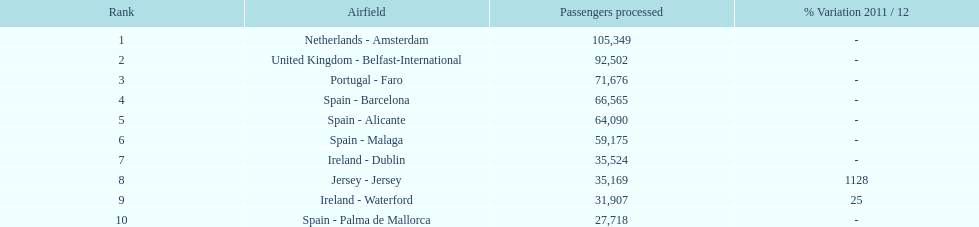What is the name of the only airport in portugal that is among the 10 busiest routes to and from london southend airport in 2012? Portugal - Faro. Give me the full table as a dictionary. {'header': ['Rank', 'Airfield', 'Passengers processed', '% Variation 2011 / 12'], 'rows': [['1', 'Netherlands - Amsterdam', '105,349', '-'], ['2', 'United Kingdom - Belfast-International', '92,502', '-'], ['3', 'Portugal - Faro', '71,676', '-'], ['4', 'Spain - Barcelona', '66,565', '-'], ['5', 'Spain - Alicante', '64,090', '-'], ['6', 'Spain - Malaga', '59,175', '-'], ['7', 'Ireland - Dublin', '35,524', '-'], ['8', 'Jersey - Jersey', '35,169', '1128'], ['9', 'Ireland - Waterford', '31,907', '25'], ['10', 'Spain - Palma de Mallorca', '27,718', '-']]} 